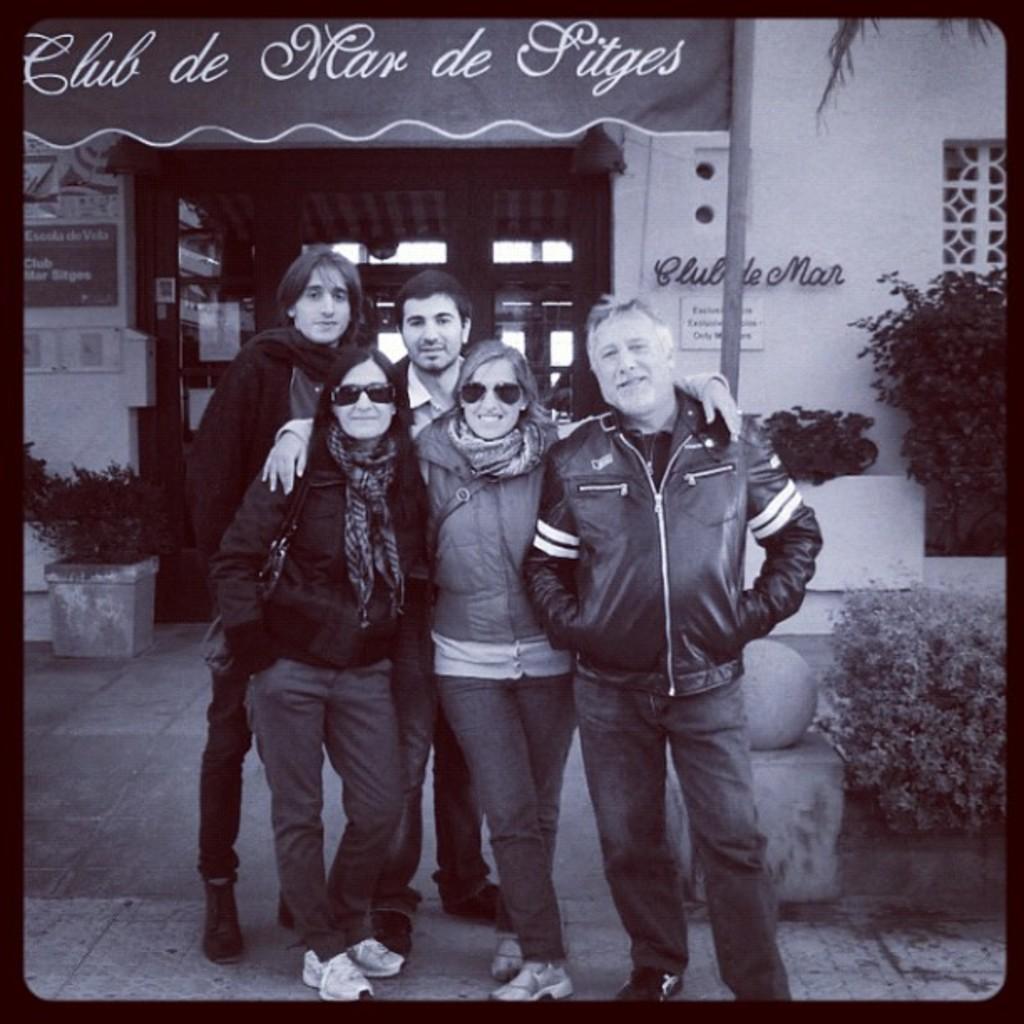Could you give a brief overview of what you see in this image? In this image there are three men and two women standing, the women are wearing bags, they are wearing goggles, there is a pole towards the top of the image, there is a flower pot towards the left of the image, there are plants, there are windows, there is a door, there are boards, there is text on the boards, there is a wall, there is text on the wall. 